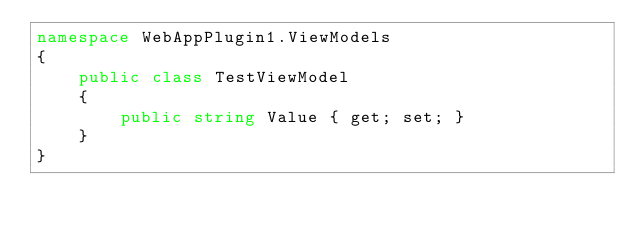<code> <loc_0><loc_0><loc_500><loc_500><_C#_>namespace WebAppPlugin1.ViewModels
{
    public class TestViewModel
    {
        public string Value { get; set; }
    }
}</code> 